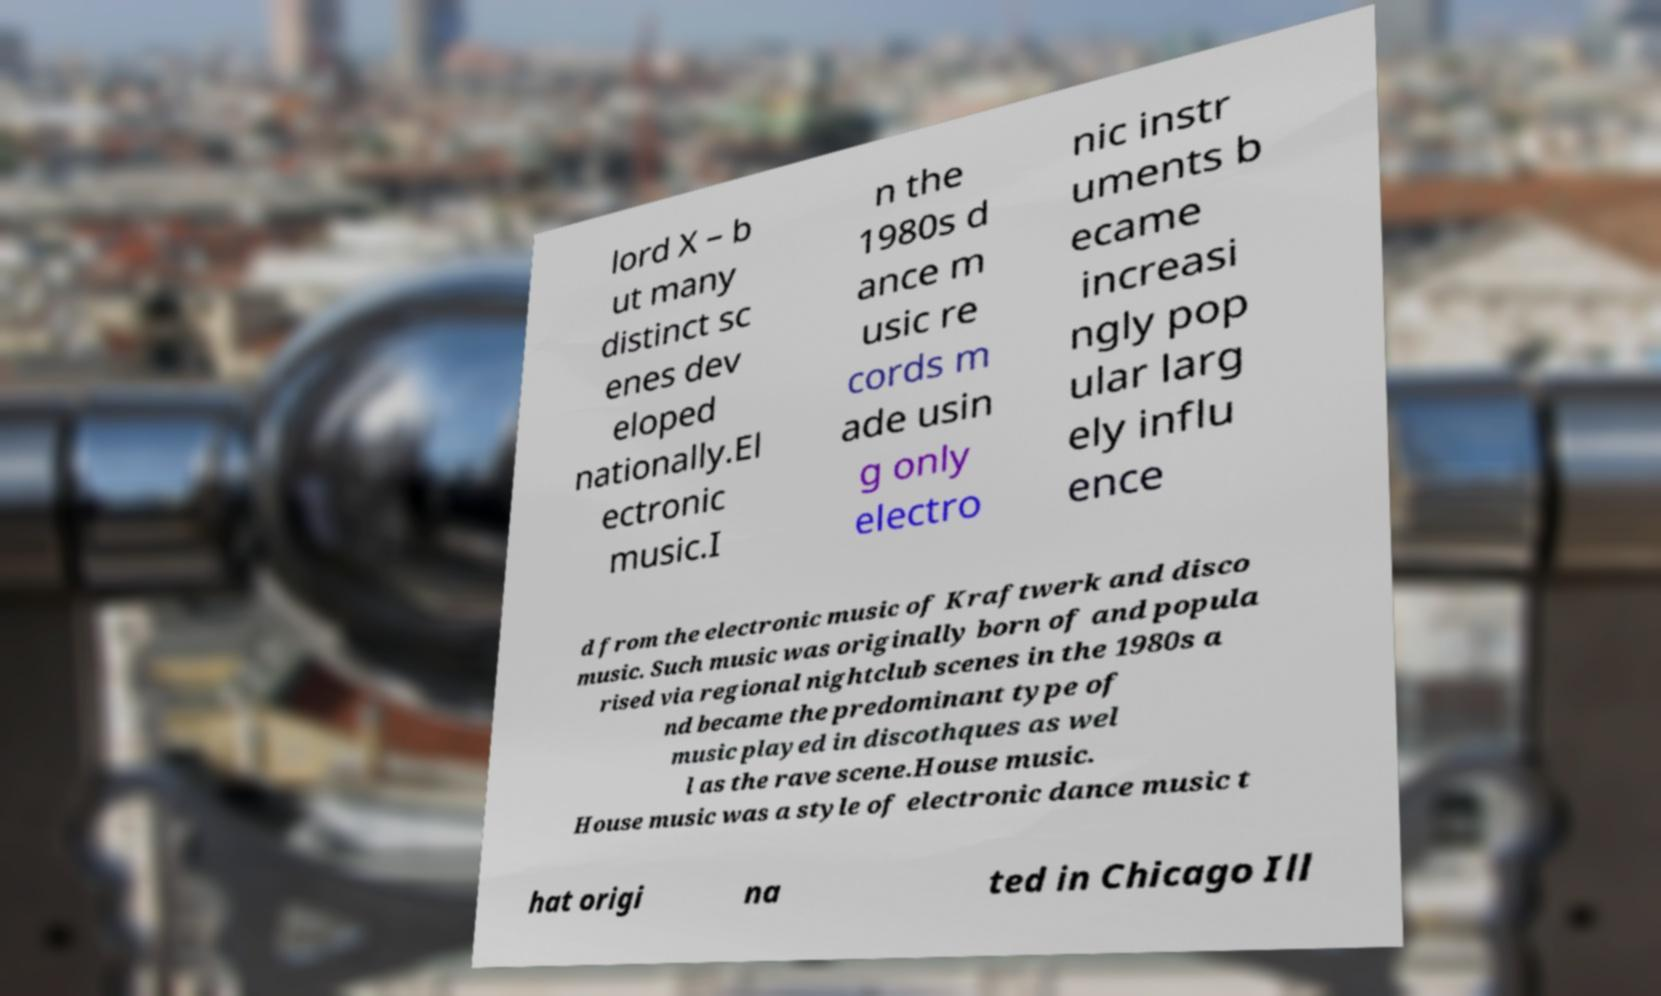Please identify and transcribe the text found in this image. lord X – b ut many distinct sc enes dev eloped nationally.El ectronic music.I n the 1980s d ance m usic re cords m ade usin g only electro nic instr uments b ecame increasi ngly pop ular larg ely influ ence d from the electronic music of Kraftwerk and disco music. Such music was originally born of and popula rised via regional nightclub scenes in the 1980s a nd became the predominant type of music played in discothques as wel l as the rave scene.House music. House music was a style of electronic dance music t hat origi na ted in Chicago Ill 